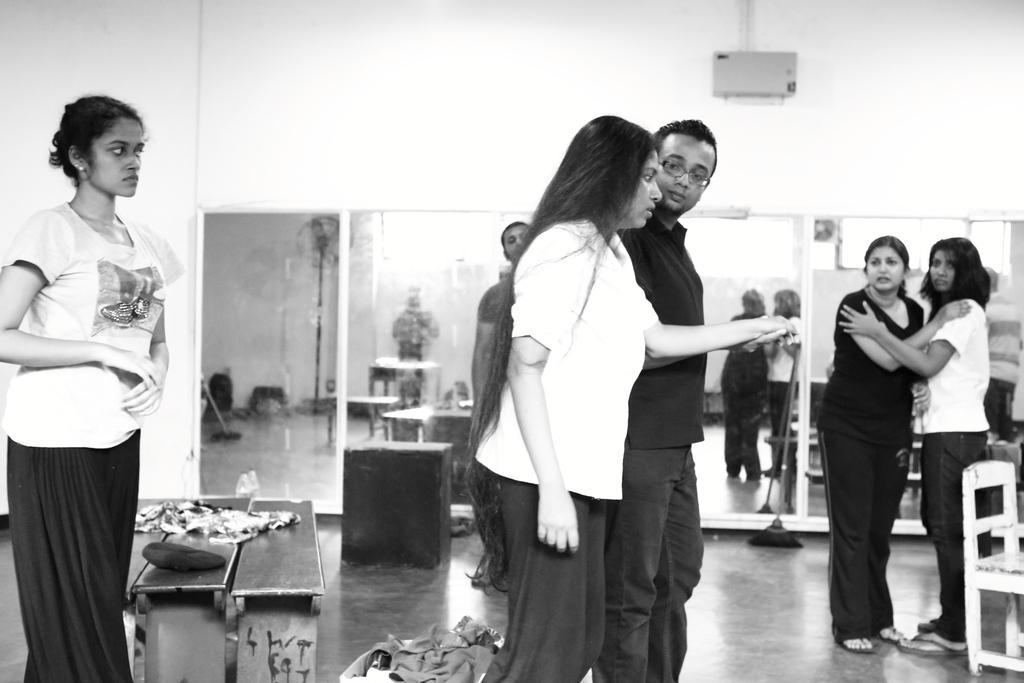Could you give a brief overview of what you see in this image? Here in this picture we can see a group of people standing on the floor over there and we can also see mirrors in the back and we can see benches and chairs also present over there. 